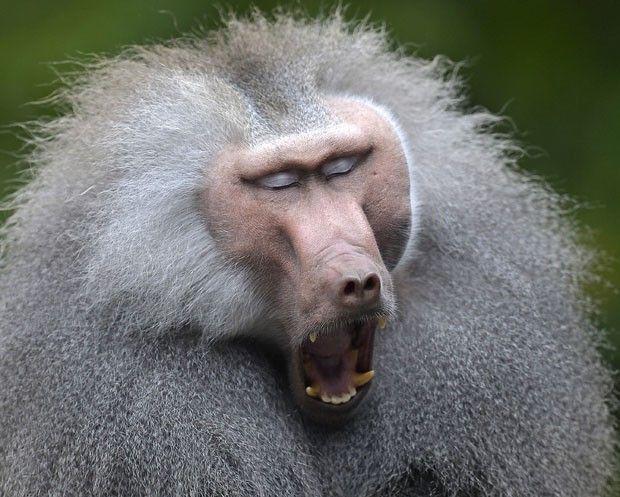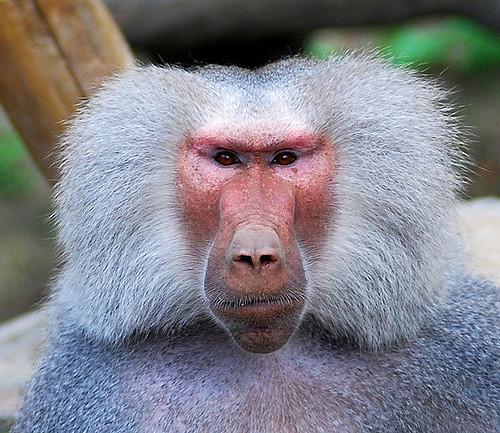The first image is the image on the left, the second image is the image on the right. Analyze the images presented: Is the assertion "The left image is of a single animal with its mouth open." valid? Answer yes or no. Yes. 